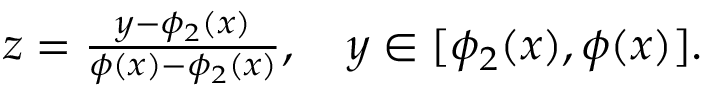Convert formula to latex. <formula><loc_0><loc_0><loc_500><loc_500>\begin{array} { r } { z = \frac { y - \phi _ { 2 } ( x ) } { \phi ( x ) - \phi _ { 2 } ( x ) } , \quad y \in [ \phi _ { 2 } ( x ) , \phi ( x ) ] . } \end{array}</formula> 